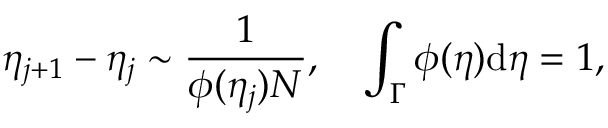Convert formula to latex. <formula><loc_0><loc_0><loc_500><loc_500>\eta _ { j + 1 } - \eta _ { j } \sim \frac { 1 } { \phi ( \eta _ { j } ) N } , \quad \int _ { \Gamma } \phi ( \eta ) d \eta = 1 ,</formula> 